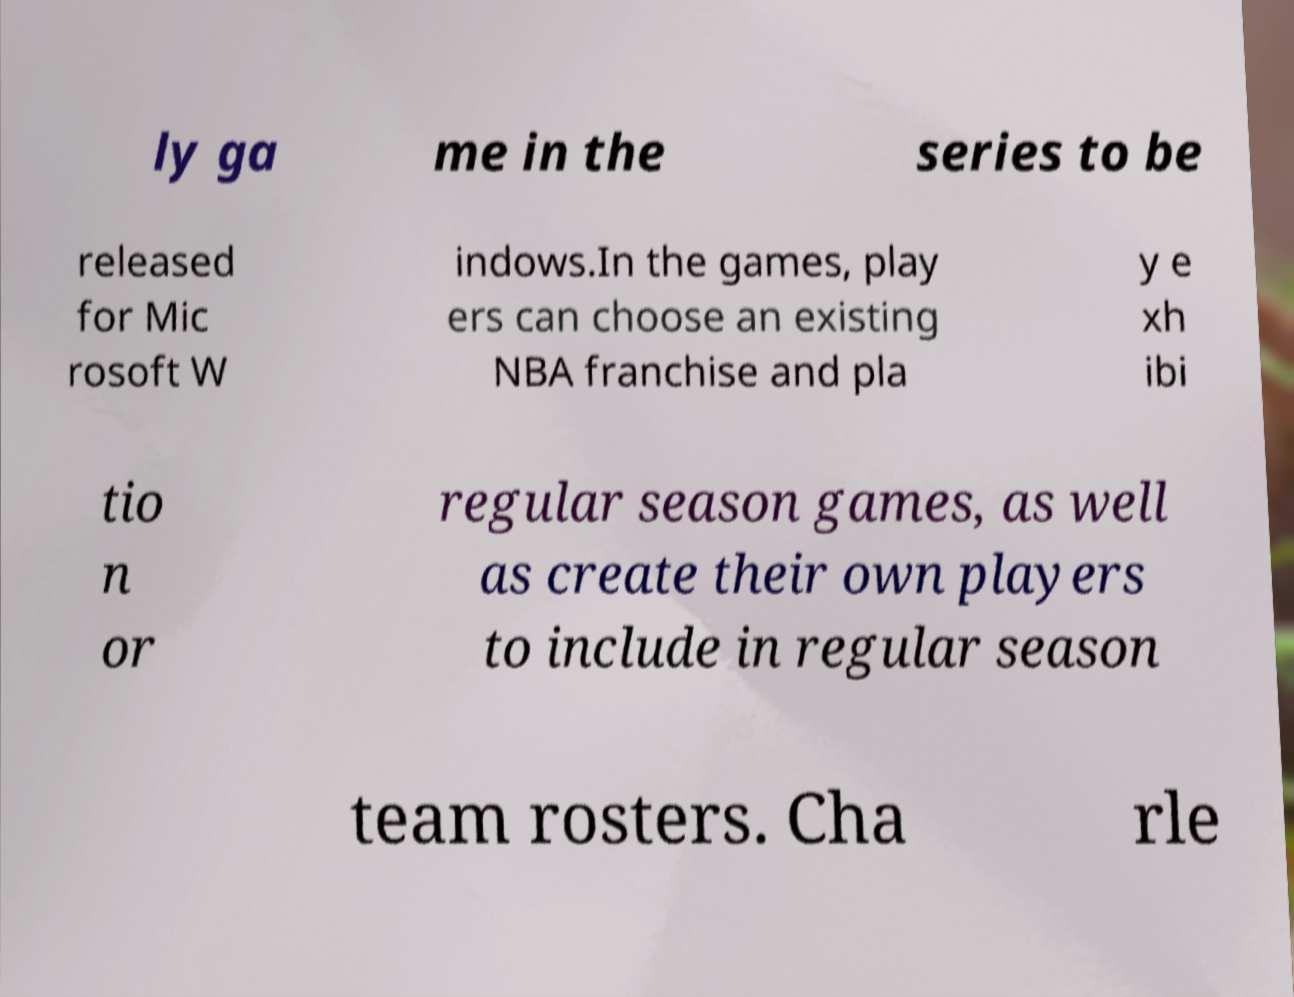Please read and relay the text visible in this image. What does it say? ly ga me in the series to be released for Mic rosoft W indows.In the games, play ers can choose an existing NBA franchise and pla y e xh ibi tio n or regular season games, as well as create their own players to include in regular season team rosters. Cha rle 